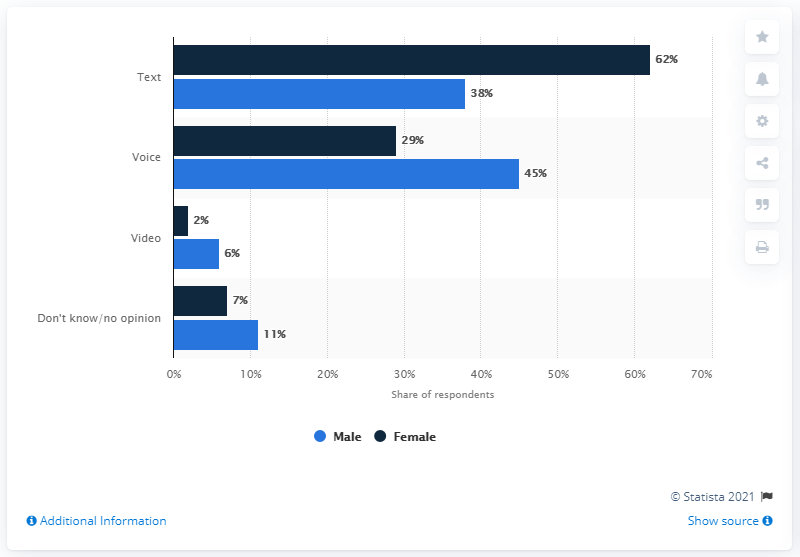Highlight a few significant elements in this photo. There are five bars that are greater than 10. The results of the study indicate that the largest difference in mobile communication preference between males and females is in the form of text messaging. 